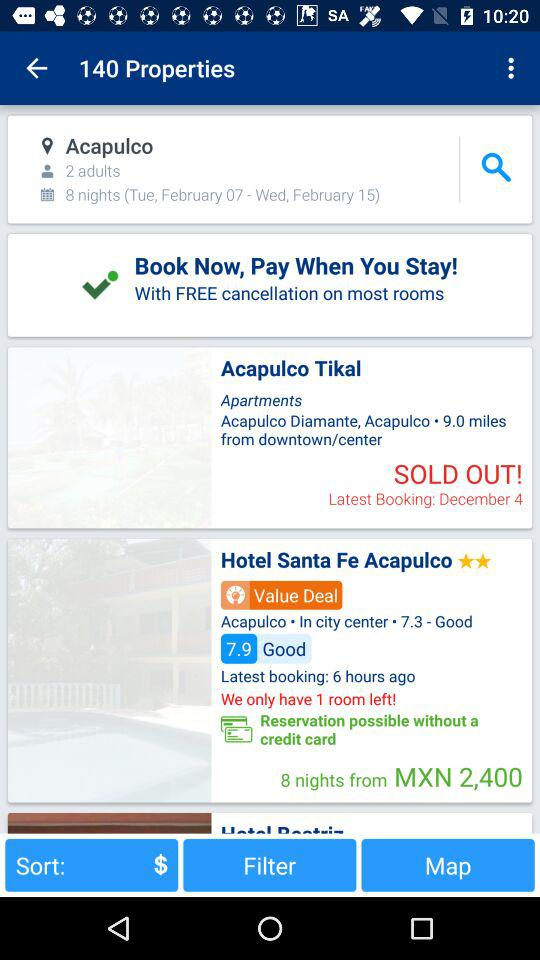How many nights are the users staying for?
Answer the question using a single word or phrase. 8 nights 